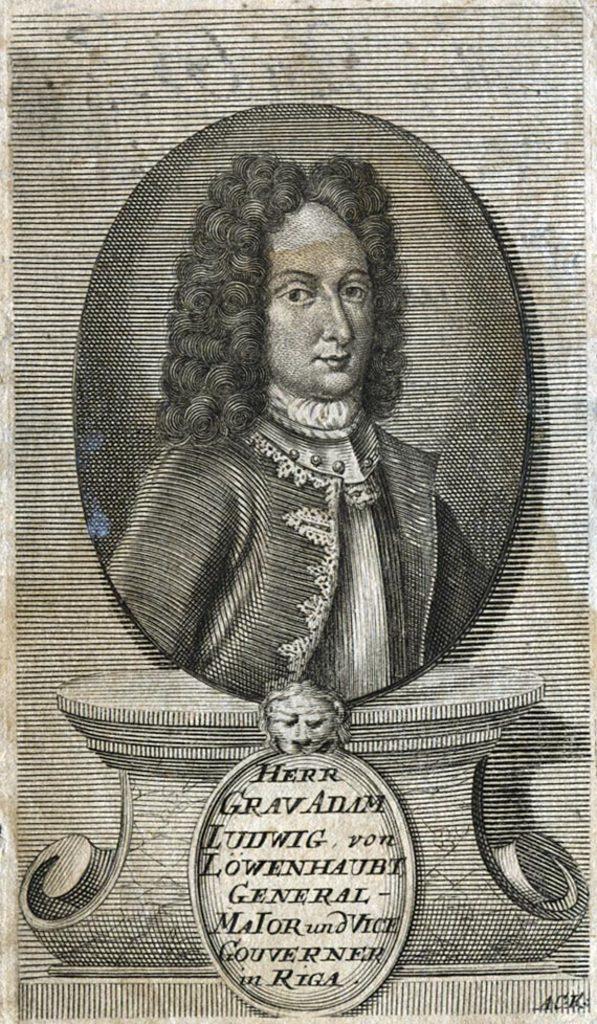Describe this image in one or two sentences. In this picture we can see a person´s photograph, at the bottom there is some text, it looks like a paper. 